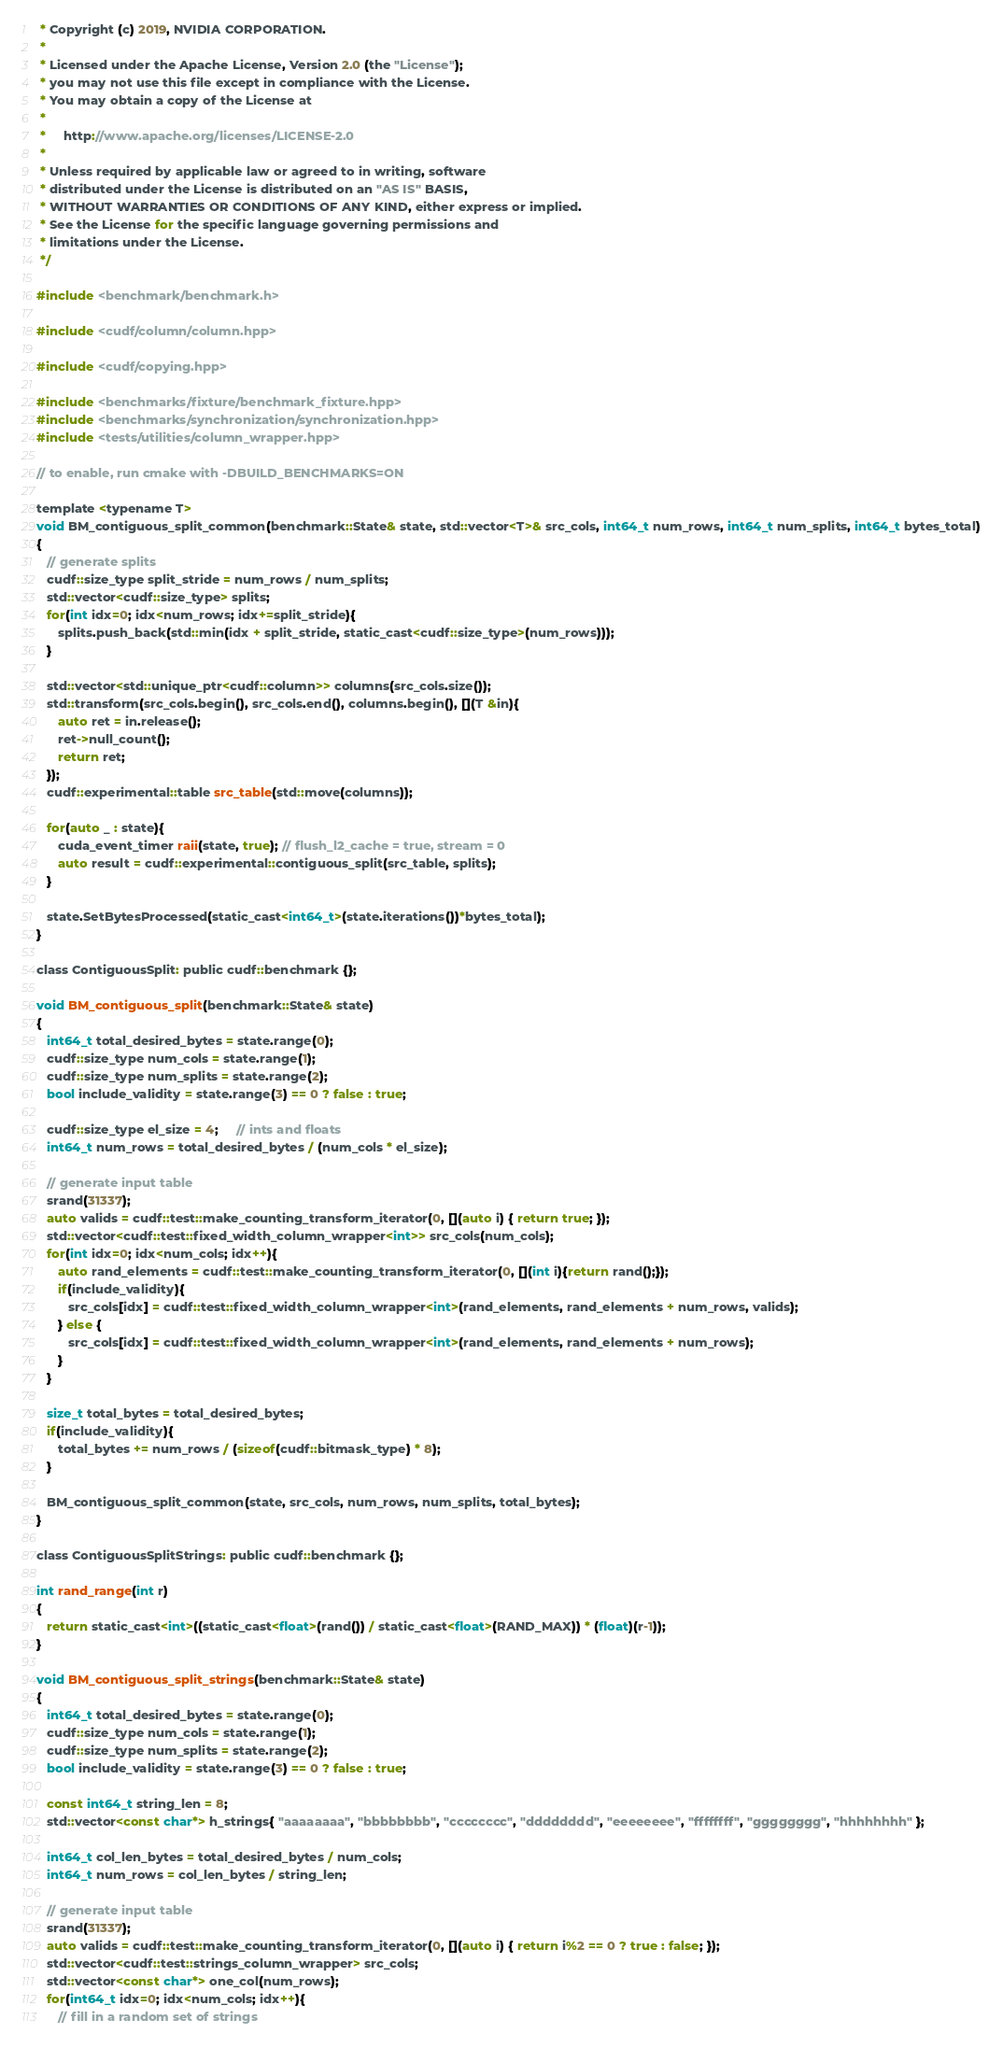<code> <loc_0><loc_0><loc_500><loc_500><_Cuda_> * Copyright (c) 2019, NVIDIA CORPORATION.
 *
 * Licensed under the Apache License, Version 2.0 (the "License");
 * you may not use this file except in compliance with the License.
 * You may obtain a copy of the License at
 *
 *     http://www.apache.org/licenses/LICENSE-2.0
 *
 * Unless required by applicable law or agreed to in writing, software
 * distributed under the License is distributed on an "AS IS" BASIS,
 * WITHOUT WARRANTIES OR CONDITIONS OF ANY KIND, either express or implied.
 * See the License for the specific language governing permissions and
 * limitations under the License.
 */

#include <benchmark/benchmark.h>

#include <cudf/column/column.hpp>

#include <cudf/copying.hpp>

#include <benchmarks/fixture/benchmark_fixture.hpp>
#include <benchmarks/synchronization/synchronization.hpp>
#include <tests/utilities/column_wrapper.hpp>

// to enable, run cmake with -DBUILD_BENCHMARKS=ON

template <typename T>
void BM_contiguous_split_common(benchmark::State& state, std::vector<T>& src_cols, int64_t num_rows, int64_t num_splits, int64_t bytes_total)
{   
   // generate splits
   cudf::size_type split_stride = num_rows / num_splits;
   std::vector<cudf::size_type> splits;
   for(int idx=0; idx<num_rows; idx+=split_stride){      
      splits.push_back(std::min(idx + split_stride, static_cast<cudf::size_type>(num_rows)));
   }

   std::vector<std::unique_ptr<cudf::column>> columns(src_cols.size());
   std::transform(src_cols.begin(), src_cols.end(), columns.begin(), [](T &in){   
      auto ret = in.release();
      ret->null_count();
      return ret;
   });
   cudf::experimental::table src_table(std::move(columns));   
      
   for(auto _ : state){
      cuda_event_timer raii(state, true); // flush_l2_cache = true, stream = 0
      auto result = cudf::experimental::contiguous_split(src_table, splits);      
   }   

   state.SetBytesProcessed(static_cast<int64_t>(state.iterations())*bytes_total);
}

class ContiguousSplit: public cudf::benchmark {};

void BM_contiguous_split(benchmark::State& state)
{   
   int64_t total_desired_bytes = state.range(0);
   cudf::size_type num_cols = state.range(1);   
   cudf::size_type num_splits = state.range(2);   
   bool include_validity = state.range(3) == 0 ? false : true;   

   cudf::size_type el_size = 4;     // ints and floats
   int64_t num_rows = total_desired_bytes / (num_cols * el_size);      

   // generate input table
   srand(31337);
   auto valids = cudf::test::make_counting_transform_iterator(0, [](auto i) { return true; });
   std::vector<cudf::test::fixed_width_column_wrapper<int>> src_cols(num_cols);
   for(int idx=0; idx<num_cols; idx++){
      auto rand_elements = cudf::test::make_counting_transform_iterator(0, [](int i){return rand();});
      if(include_validity){
         src_cols[idx] = cudf::test::fixed_width_column_wrapper<int>(rand_elements, rand_elements + num_rows, valids);
      } else {
         src_cols[idx] = cudf::test::fixed_width_column_wrapper<int>(rand_elements, rand_elements + num_rows);
      }
   }

   size_t total_bytes = total_desired_bytes;
   if(include_validity){
      total_bytes += num_rows / (sizeof(cudf::bitmask_type) * 8);
   }

   BM_contiguous_split_common(state, src_cols, num_rows, num_splits, total_bytes);
}

class ContiguousSplitStrings: public cudf::benchmark {};

int rand_range(int r)
{
   return static_cast<int>((static_cast<float>(rand()) / static_cast<float>(RAND_MAX)) * (float)(r-1));
}

void BM_contiguous_split_strings(benchmark::State& state)
{   
   int64_t total_desired_bytes = state.range(0);
   cudf::size_type num_cols = state.range(1);   
   cudf::size_type num_splits = state.range(2);   
   bool include_validity = state.range(3) == 0 ? false : true;   

   const int64_t string_len = 8;         
   std::vector<const char*> h_strings{ "aaaaaaaa", "bbbbbbbb", "cccccccc", "dddddddd", "eeeeeeee", "ffffffff", "gggggggg", "hhhhhhhh" };   
   
   int64_t col_len_bytes = total_desired_bytes / num_cols;
   int64_t num_rows = col_len_bytes / string_len;

   // generate input table
   srand(31337);
   auto valids = cudf::test::make_counting_transform_iterator(0, [](auto i) { return i%2 == 0 ? true : false; });   
   std::vector<cudf::test::strings_column_wrapper> src_cols;   
   std::vector<const char*> one_col(num_rows);
   for(int64_t idx=0; idx<num_cols; idx++){
      // fill in a random set of strings</code> 